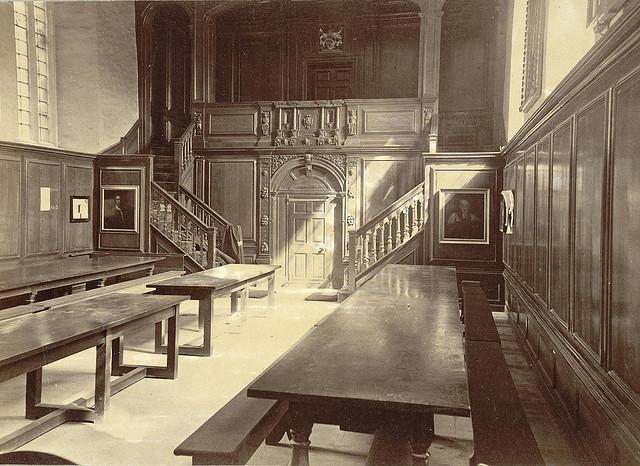Where are the portraits?
Quick response, please. Wall. Could this be a boarding school cafeteria?
Short answer required. Yes. Is it sunny?
Concise answer only. Yes. Is there a bench for every table?
Write a very short answer. No. 